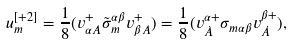<formula> <loc_0><loc_0><loc_500><loc_500>u ^ { [ + 2 ] } _ { m } = \frac { 1 } { 8 } ( v ^ { + } _ { \alpha A } \tilde { \sigma } _ { m } ^ { \alpha \beta } v ^ { + } _ { \beta A } ) = \frac { 1 } { 8 } ( v ^ { \alpha + } _ { \dot { A } } \sigma _ { m \alpha \beta } v ^ { \beta + } _ { \dot { A } } ) ,</formula> 